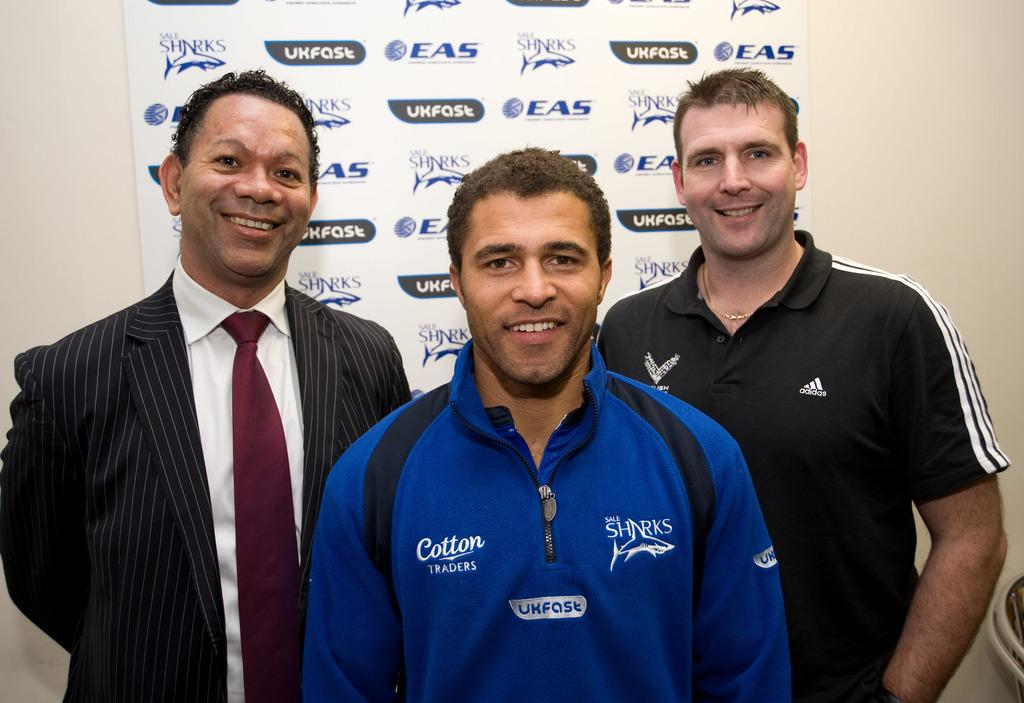<image>
Render a clear and concise summary of the photo. Man wearing a blue sweater that says Cotton on it. 